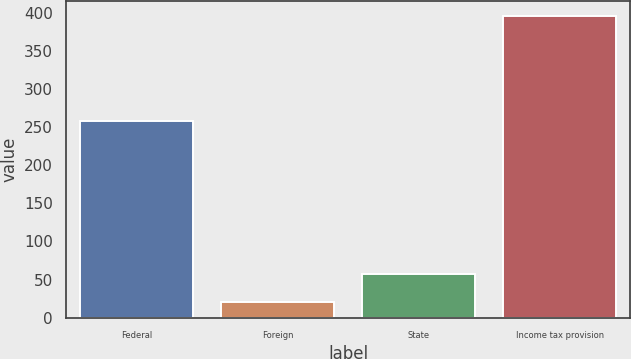Convert chart. <chart><loc_0><loc_0><loc_500><loc_500><bar_chart><fcel>Federal<fcel>Foreign<fcel>State<fcel>Income tax provision<nl><fcel>258.1<fcel>20.1<fcel>57.67<fcel>395.8<nl></chart> 